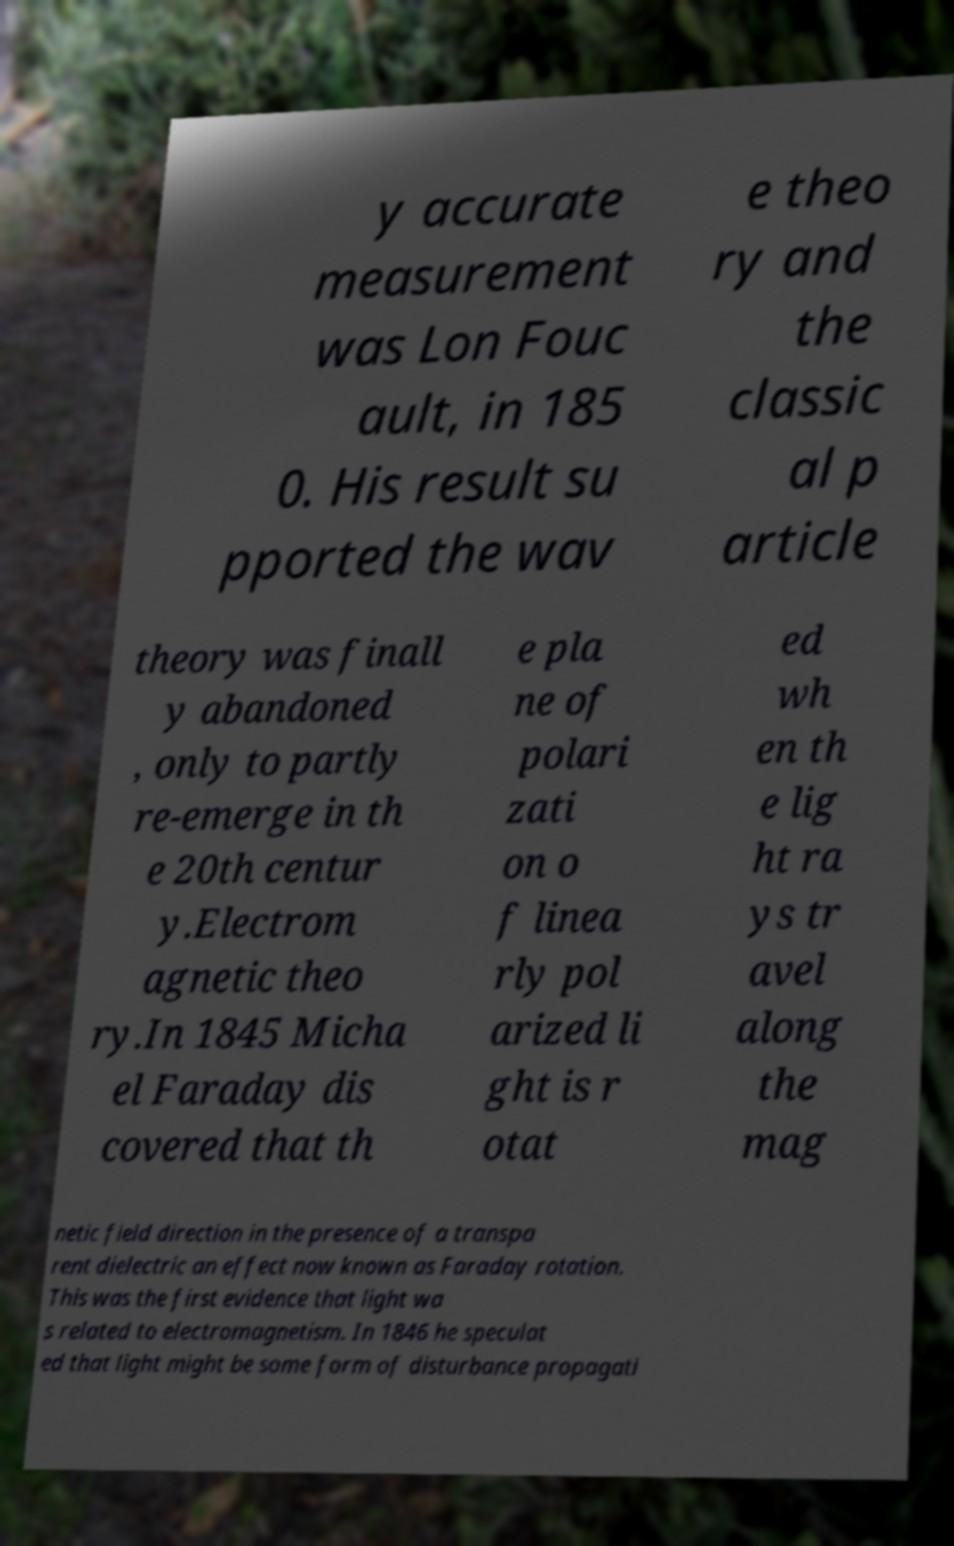Please read and relay the text visible in this image. What does it say? y accurate measurement was Lon Fouc ault, in 185 0. His result su pported the wav e theo ry and the classic al p article theory was finall y abandoned , only to partly re-emerge in th e 20th centur y.Electrom agnetic theo ry.In 1845 Micha el Faraday dis covered that th e pla ne of polari zati on o f linea rly pol arized li ght is r otat ed wh en th e lig ht ra ys tr avel along the mag netic field direction in the presence of a transpa rent dielectric an effect now known as Faraday rotation. This was the first evidence that light wa s related to electromagnetism. In 1846 he speculat ed that light might be some form of disturbance propagati 